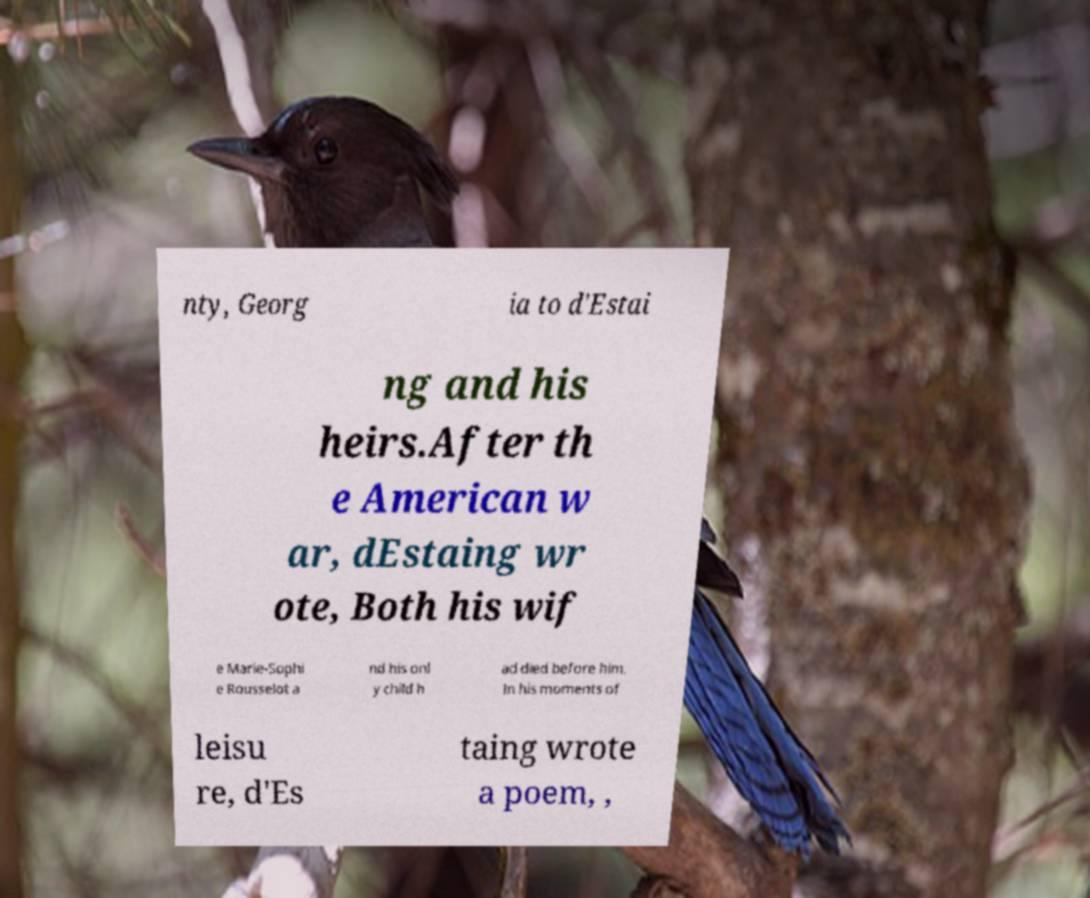Please identify and transcribe the text found in this image. nty, Georg ia to d'Estai ng and his heirs.After th e American w ar, dEstaing wr ote, Both his wif e Marie-Sophi e Rousselot a nd his onl y child h ad died before him. In his moments of leisu re, d'Es taing wrote a poem, , 